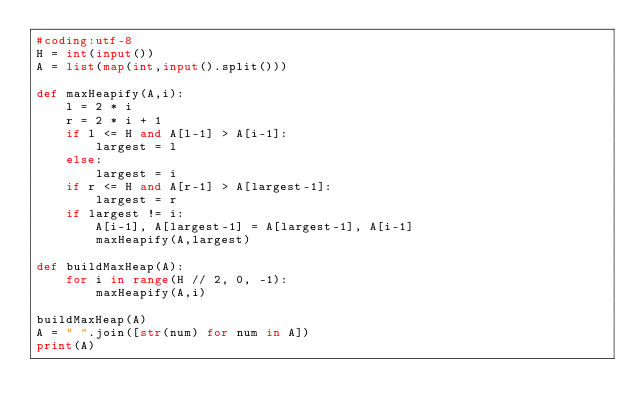<code> <loc_0><loc_0><loc_500><loc_500><_Python_>#coding:utf-8
H = int(input())
A = list(map(int,input().split()))

def maxHeapify(A,i):
    l = 2 * i
    r = 2 * i + 1
    if l <= H and A[l-1] > A[i-1]:
        largest = l
    else:
        largest = i
    if r <= H and A[r-1] > A[largest-1]:
        largest = r
    if largest != i:
        A[i-1], A[largest-1] = A[largest-1], A[i-1]
        maxHeapify(A,largest)

def buildMaxHeap(A):
    for i in range(H // 2, 0, -1):
        maxHeapify(A,i)

buildMaxHeap(A)
A = " ".join([str(num) for num in A])
print(A)

</code> 